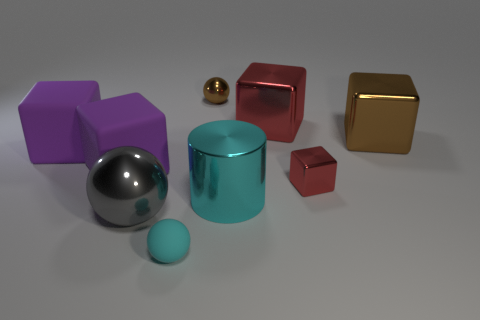Subtract all brown cubes. How many cubes are left? 4 Subtract all brown cubes. How many cubes are left? 4 Subtract all yellow cubes. Subtract all blue balls. How many cubes are left? 5 Add 1 big green rubber cylinders. How many objects exist? 10 Subtract all cylinders. How many objects are left? 8 Subtract all blue matte objects. Subtract all large cubes. How many objects are left? 5 Add 6 brown metallic objects. How many brown metallic objects are left? 8 Add 8 shiny cylinders. How many shiny cylinders exist? 9 Subtract 0 purple cylinders. How many objects are left? 9 